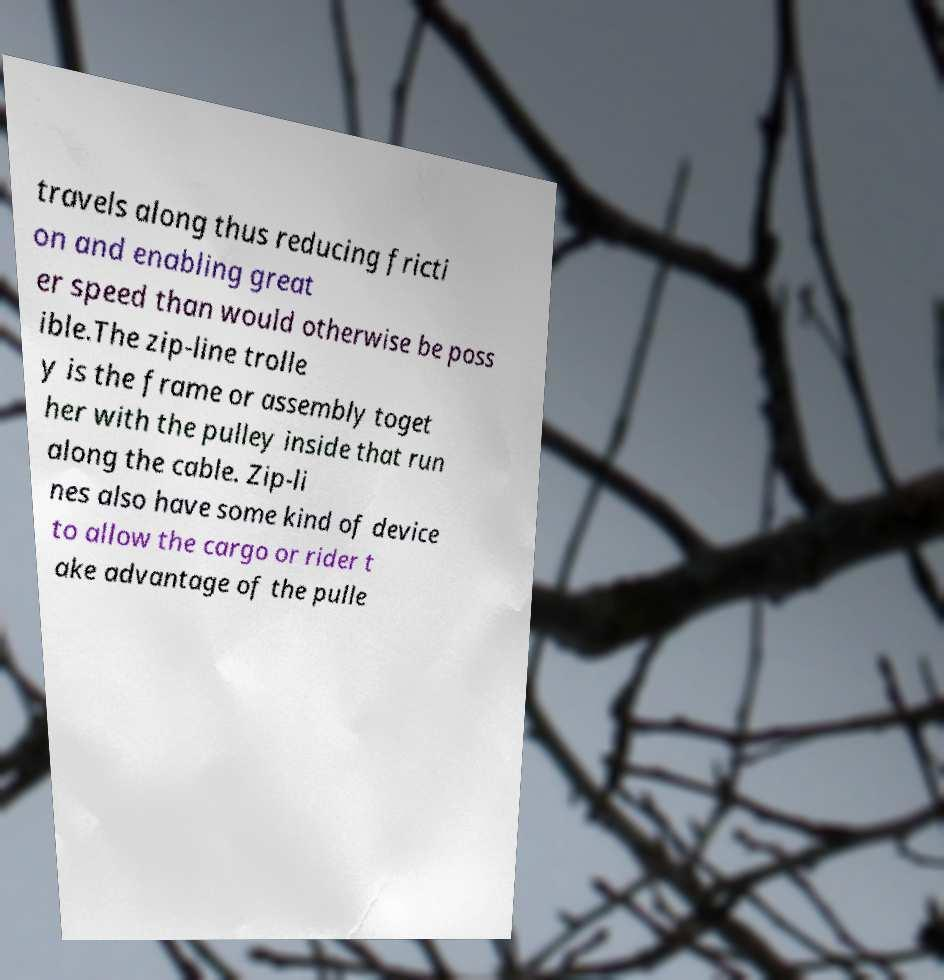Could you extract and type out the text from this image? travels along thus reducing fricti on and enabling great er speed than would otherwise be poss ible.The zip-line trolle y is the frame or assembly toget her with the pulley inside that run along the cable. Zip-li nes also have some kind of device to allow the cargo or rider t ake advantage of the pulle 